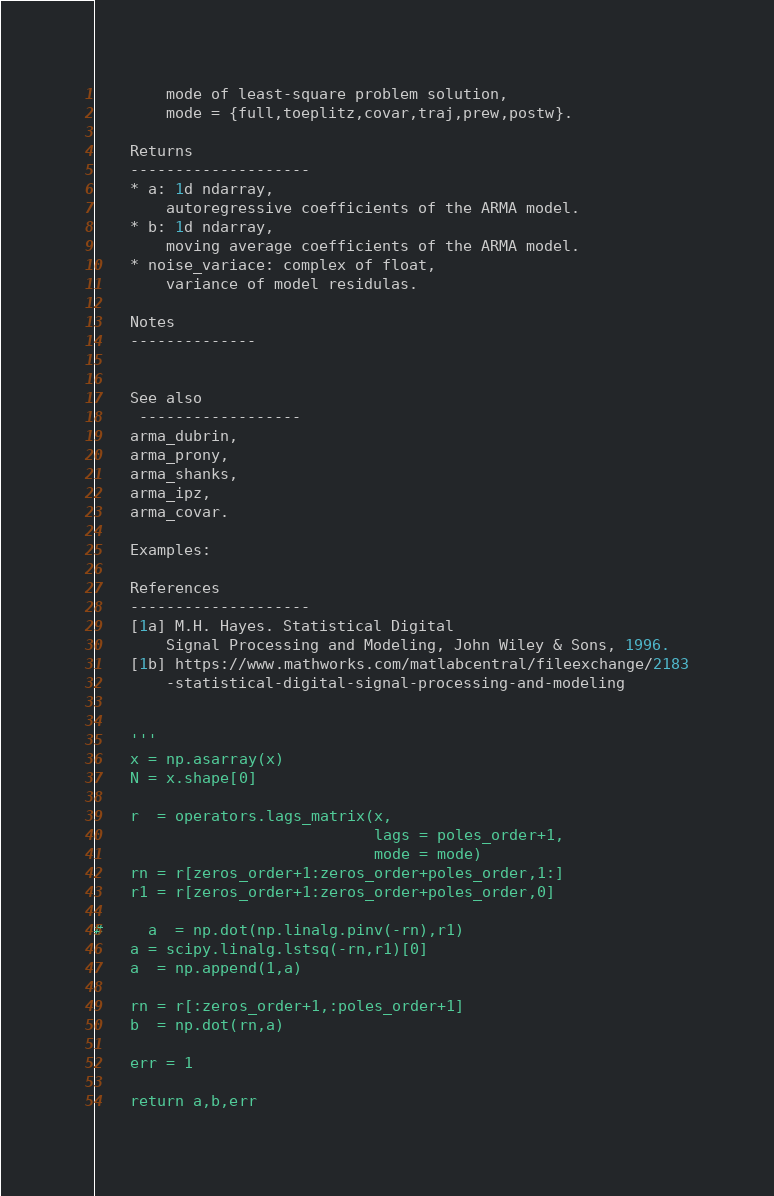Convert code to text. <code><loc_0><loc_0><loc_500><loc_500><_Python_>        mode of least-square problem solution,
        mode = {full,toeplitz,covar,traj,prew,postw}.
        
    Returns
    --------------------
    * a: 1d ndarray,
        autoregressive coefficients of the ARMA model.
    * b: 1d ndarray,
        moving average coefficients of the ARMA model.        
    * noise_variace: complex of float,
        variance of model residulas.
    
    Notes
    --------------
   
    
    See also
     ------------------
    arma_dubrin,
    arma_prony,
    arma_shanks,
    arma_ipz,
    arma_covar. 
    
    Examples:
    
    References
    --------------------
    [1a] M.H. Hayes. Statistical Digital 
        Signal Processing and Modeling, John Wiley & Sons, 1996.
    [1b] https://www.mathworks.com/matlabcentral/fileexchange/2183
        -statistical-digital-signal-processing-and-modeling

    
    ''' 
    x = np.asarray(x)
    N = x.shape[0]

    r  = operators.lags_matrix(x,
                               lags = poles_order+1, 
                               mode = mode)
    rn = r[zeros_order+1:zeros_order+poles_order,1:]
    r1 = r[zeros_order+1:zeros_order+poles_order,0]
    
#     a  = np.dot(np.linalg.pinv(-rn),r1)
    a = scipy.linalg.lstsq(-rn,r1)[0]
    a  = np.append(1,a)
    
    rn = r[:zeros_order+1,:poles_order+1]
    b  = np.dot(rn,a)
   
    err = 1

    return a,b,err



</code> 